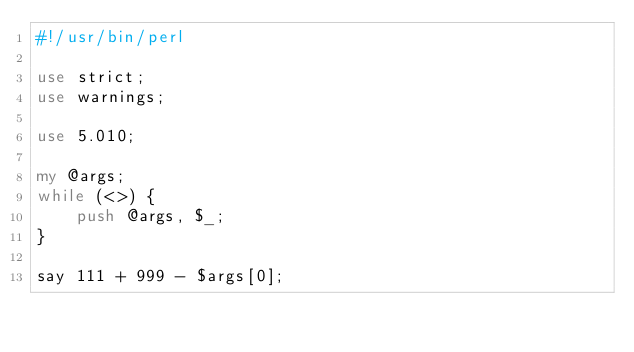<code> <loc_0><loc_0><loc_500><loc_500><_Perl_>#!/usr/bin/perl

use strict;
use warnings;

use 5.010;

my @args;
while (<>) {
    push @args, $_;
}

say 111 + 999 - $args[0];
</code> 